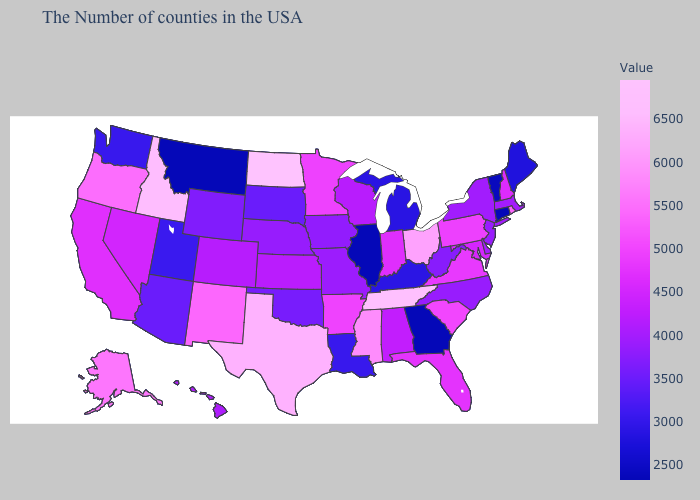Among the states that border Idaho , does Wyoming have the lowest value?
Answer briefly. No. Which states have the lowest value in the USA?
Short answer required. Connecticut, Georgia, Illinois, Montana. Among the states that border Arkansas , which have the lowest value?
Give a very brief answer. Louisiana. Among the states that border Illinois , which have the highest value?
Write a very short answer. Indiana. Among the states that border Mississippi , does Louisiana have the lowest value?
Give a very brief answer. Yes. Does Oregon have the lowest value in the USA?
Give a very brief answer. No. Does California have a lower value than Oregon?
Keep it brief. Yes. 